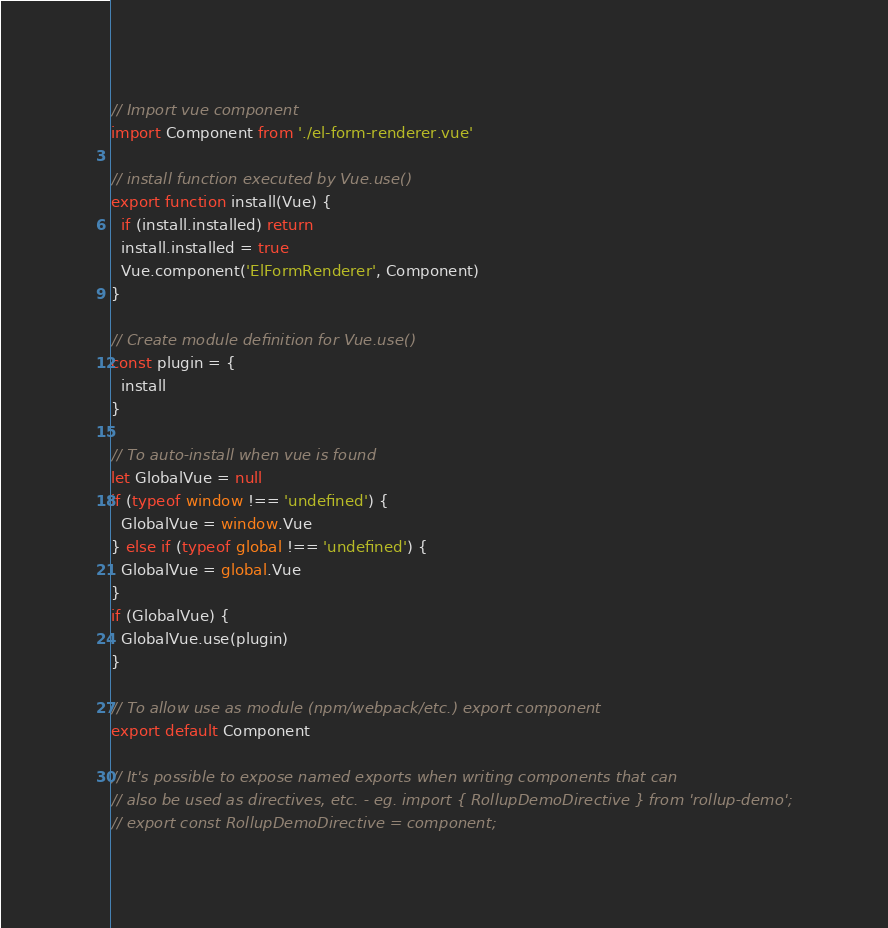Convert code to text. <code><loc_0><loc_0><loc_500><loc_500><_JavaScript_>// Import vue component
import Component from './el-form-renderer.vue'

// install function executed by Vue.use()
export function install(Vue) {
  if (install.installed) return
  install.installed = true
  Vue.component('ElFormRenderer', Component)
}

// Create module definition for Vue.use()
const plugin = {
  install
}

// To auto-install when vue is found
let GlobalVue = null
if (typeof window !== 'undefined') {
  GlobalVue = window.Vue
} else if (typeof global !== 'undefined') {
  GlobalVue = global.Vue
}
if (GlobalVue) {
  GlobalVue.use(plugin)
}

// To allow use as module (npm/webpack/etc.) export component
export default Component

// It's possible to expose named exports when writing components that can
// also be used as directives, etc. - eg. import { RollupDemoDirective } from 'rollup-demo';
// export const RollupDemoDirective = component;
</code> 